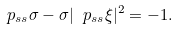<formula> <loc_0><loc_0><loc_500><loc_500>\ p _ { s s } \sigma - \sigma | \ p _ { s s } \xi | ^ { 2 } = - 1 .</formula> 